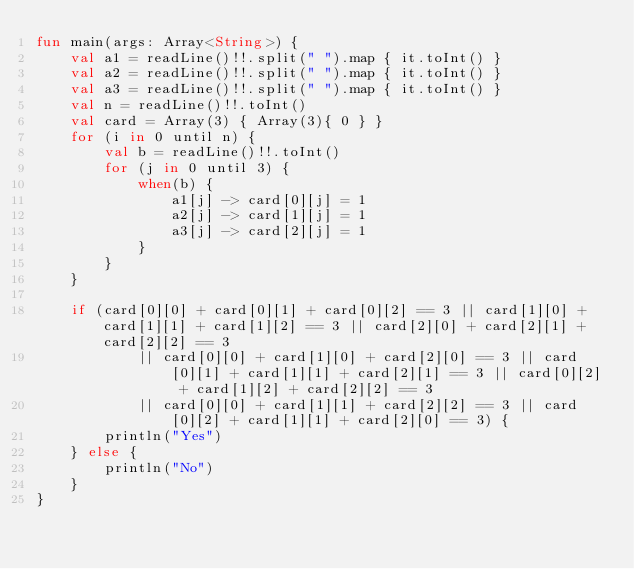<code> <loc_0><loc_0><loc_500><loc_500><_Kotlin_>fun main(args: Array<String>) {
    val a1 = readLine()!!.split(" ").map { it.toInt() }
    val a2 = readLine()!!.split(" ").map { it.toInt() }
    val a3 = readLine()!!.split(" ").map { it.toInt() }
    val n = readLine()!!.toInt()
    val card = Array(3) { Array(3){ 0 } }
    for (i in 0 until n) {
        val b = readLine()!!.toInt()
        for (j in 0 until 3) {
            when(b) {
                a1[j] -> card[0][j] = 1
                a2[j] -> card[1][j] = 1
                a3[j] -> card[2][j] = 1
            }
        }
    }

    if (card[0][0] + card[0][1] + card[0][2] == 3 || card[1][0] + card[1][1] + card[1][2] == 3 || card[2][0] + card[2][1] + card[2][2] == 3
            || card[0][0] + card[1][0] + card[2][0] == 3 || card[0][1] + card[1][1] + card[2][1] == 3 || card[0][2] + card[1][2] + card[2][2] == 3
            || card[0][0] + card[1][1] + card[2][2] == 3 || card[0][2] + card[1][1] + card[2][0] == 3) {
        println("Yes")
    } else {
        println("No")
    }
}</code> 